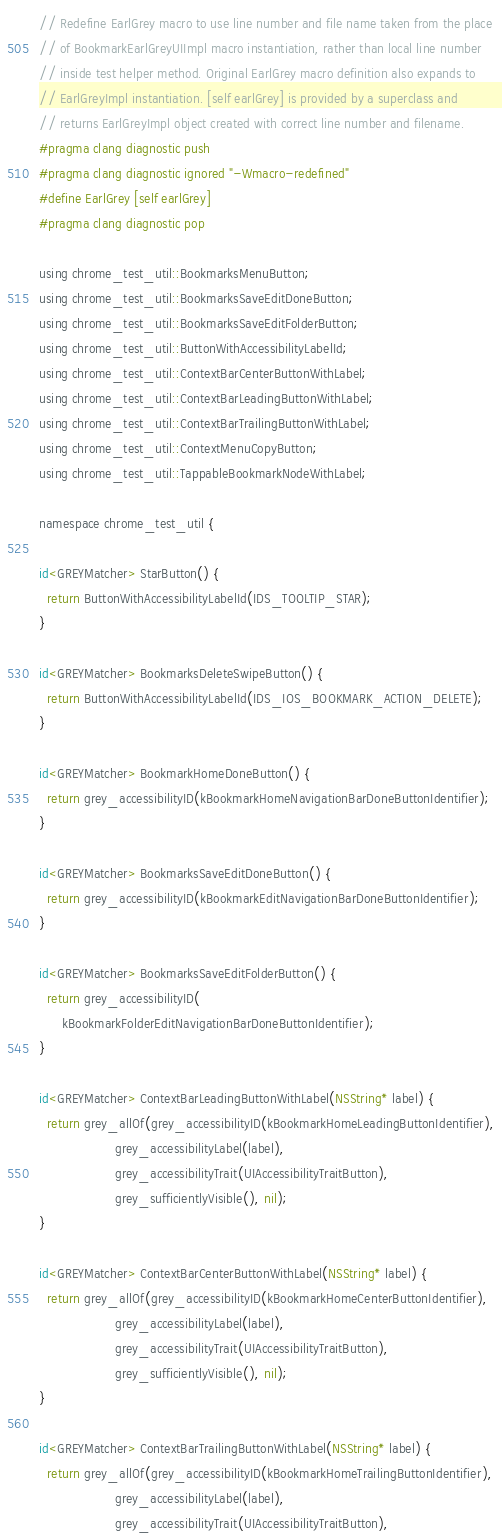Convert code to text. <code><loc_0><loc_0><loc_500><loc_500><_ObjectiveC_>
// Redefine EarlGrey macro to use line number and file name taken from the place
// of BookmarkEarlGreyUIImpl macro instantiation, rather than local line number
// inside test helper method. Original EarlGrey macro definition also expands to
// EarlGreyImpl instantiation. [self earlGrey] is provided by a superclass and
// returns EarlGreyImpl object created with correct line number and filename.
#pragma clang diagnostic push
#pragma clang diagnostic ignored "-Wmacro-redefined"
#define EarlGrey [self earlGrey]
#pragma clang diagnostic pop

using chrome_test_util::BookmarksMenuButton;
using chrome_test_util::BookmarksSaveEditDoneButton;
using chrome_test_util::BookmarksSaveEditFolderButton;
using chrome_test_util::ButtonWithAccessibilityLabelId;
using chrome_test_util::ContextBarCenterButtonWithLabel;
using chrome_test_util::ContextBarLeadingButtonWithLabel;
using chrome_test_util::ContextBarTrailingButtonWithLabel;
using chrome_test_util::ContextMenuCopyButton;
using chrome_test_util::TappableBookmarkNodeWithLabel;

namespace chrome_test_util {

id<GREYMatcher> StarButton() {
  return ButtonWithAccessibilityLabelId(IDS_TOOLTIP_STAR);
}

id<GREYMatcher> BookmarksDeleteSwipeButton() {
  return ButtonWithAccessibilityLabelId(IDS_IOS_BOOKMARK_ACTION_DELETE);
}

id<GREYMatcher> BookmarkHomeDoneButton() {
  return grey_accessibilityID(kBookmarkHomeNavigationBarDoneButtonIdentifier);
}

id<GREYMatcher> BookmarksSaveEditDoneButton() {
  return grey_accessibilityID(kBookmarkEditNavigationBarDoneButtonIdentifier);
}

id<GREYMatcher> BookmarksSaveEditFolderButton() {
  return grey_accessibilityID(
      kBookmarkFolderEditNavigationBarDoneButtonIdentifier);
}

id<GREYMatcher> ContextBarLeadingButtonWithLabel(NSString* label) {
  return grey_allOf(grey_accessibilityID(kBookmarkHomeLeadingButtonIdentifier),
                    grey_accessibilityLabel(label),
                    grey_accessibilityTrait(UIAccessibilityTraitButton),
                    grey_sufficientlyVisible(), nil);
}

id<GREYMatcher> ContextBarCenterButtonWithLabel(NSString* label) {
  return grey_allOf(grey_accessibilityID(kBookmarkHomeCenterButtonIdentifier),
                    grey_accessibilityLabel(label),
                    grey_accessibilityTrait(UIAccessibilityTraitButton),
                    grey_sufficientlyVisible(), nil);
}

id<GREYMatcher> ContextBarTrailingButtonWithLabel(NSString* label) {
  return grey_allOf(grey_accessibilityID(kBookmarkHomeTrailingButtonIdentifier),
                    grey_accessibilityLabel(label),
                    grey_accessibilityTrait(UIAccessibilityTraitButton),</code> 